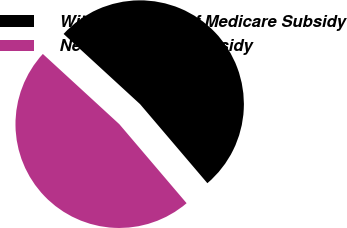Convert chart. <chart><loc_0><loc_0><loc_500><loc_500><pie_chart><fcel>Without Impact of Medicare Subsidy<fcel>Net of Medicare Subsidy<nl><fcel>51.95%<fcel>48.05%<nl></chart> 